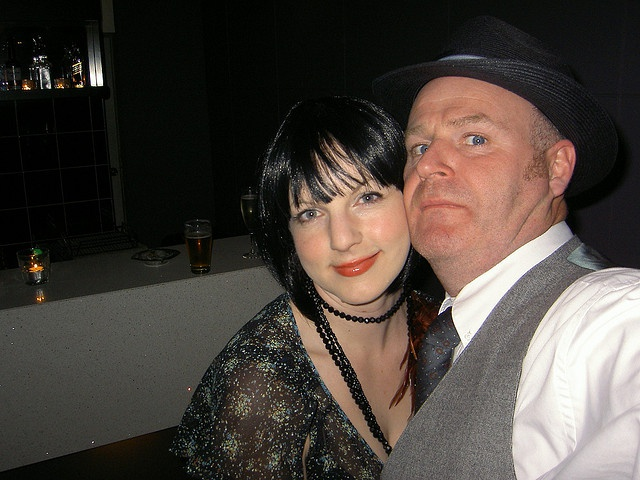Describe the objects in this image and their specific colors. I can see people in black, lightgray, gray, and salmon tones, people in black, gray, and tan tones, tie in black, gray, and maroon tones, cup in black, darkgreen, gray, and maroon tones, and wine glass in black, gray, and darkgreen tones in this image. 